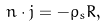<formula> <loc_0><loc_0><loc_500><loc_500>n \cdot j = - \rho _ { s } R ,</formula> 